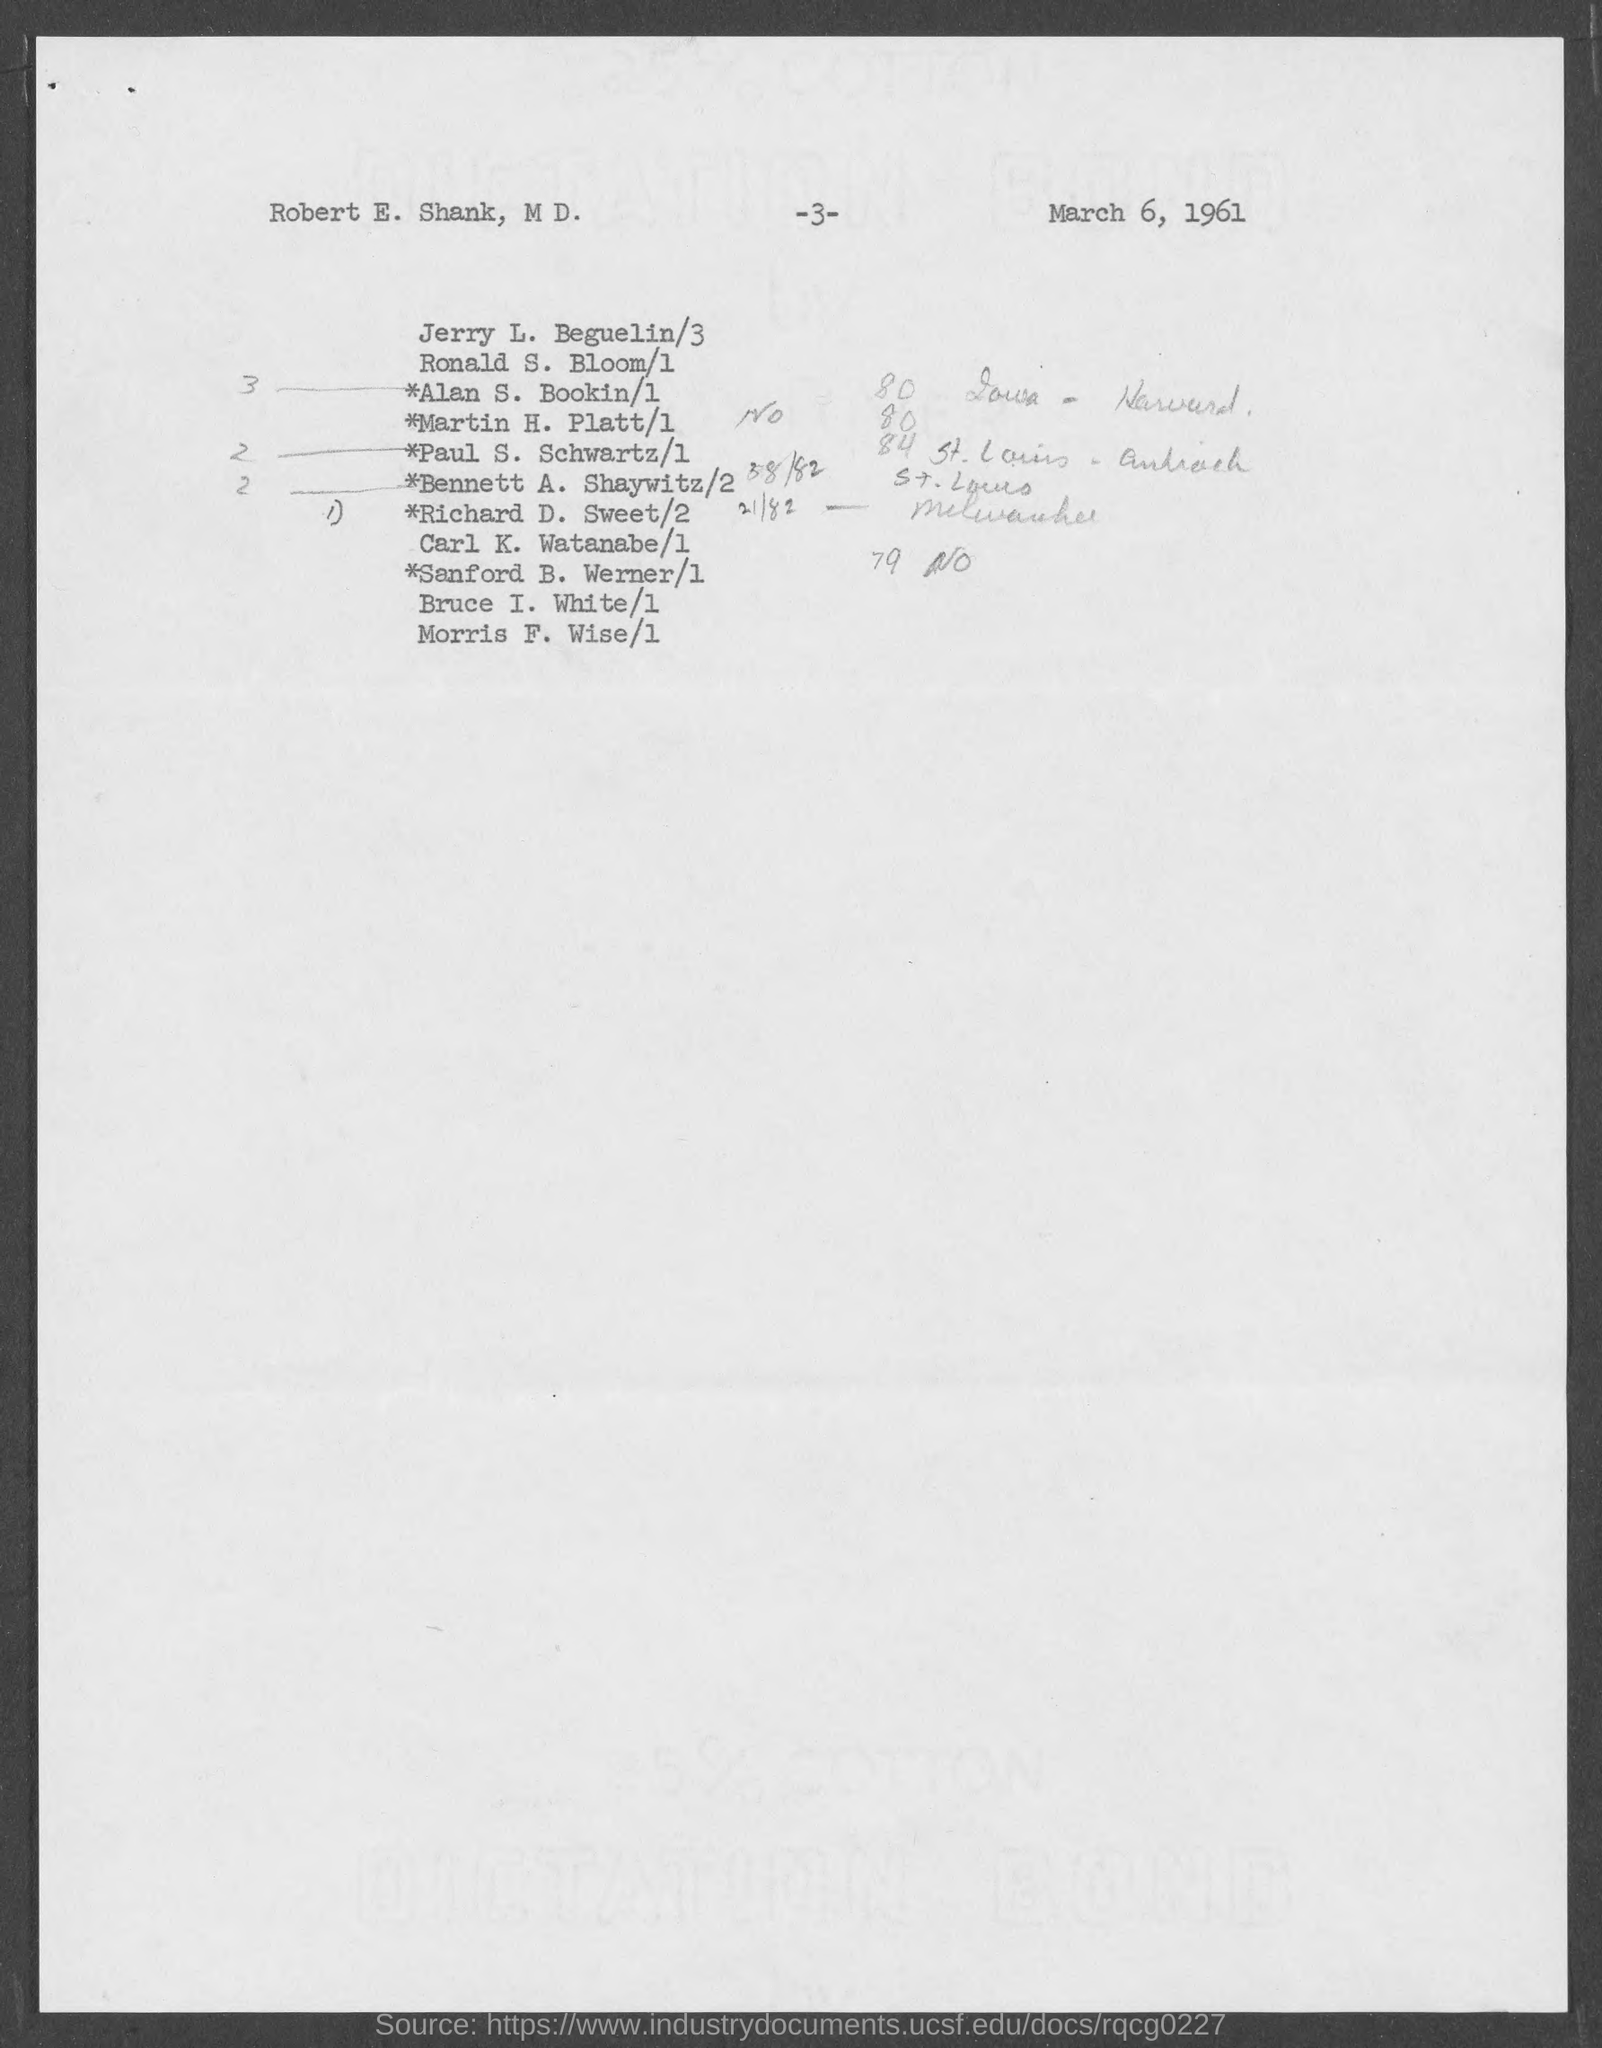What is the page number?
Your answer should be compact. 3. What is the date mentioned in the document?
Your answer should be compact. March 6, 1961. 